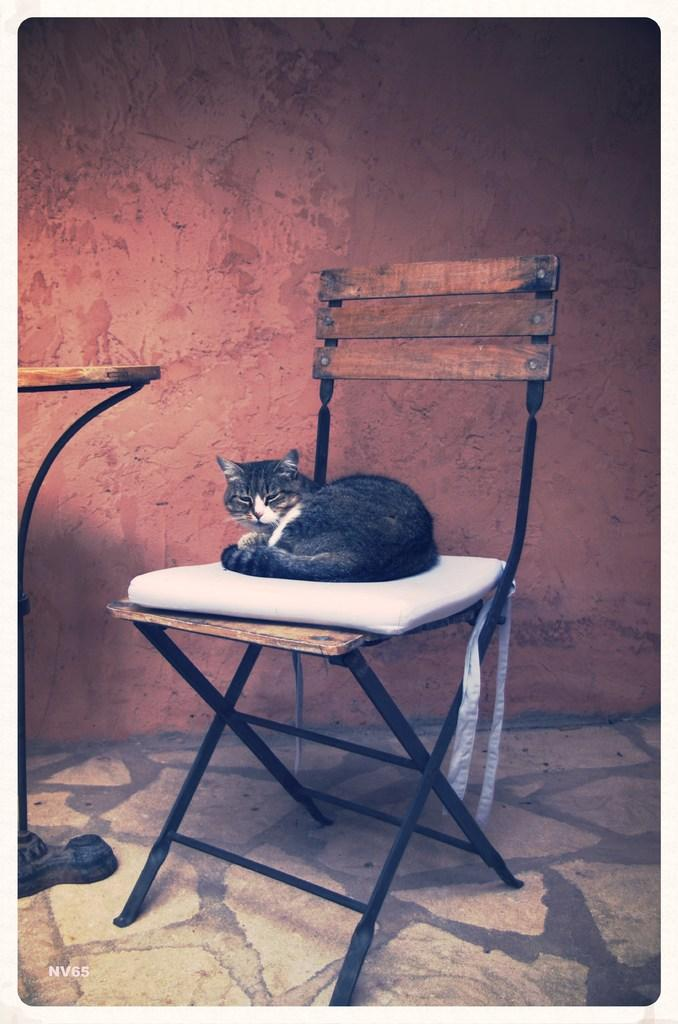What piece of furniture is present in the image? There is a chair in the image. What is placed on the chair? There is a pillow on the chair. What type of animal is sitting on the pillow? There is a black color cat on the pillow. What can be seen behind the chair in the image? There is a wall visible in the background of the image. Where is the comb used by the cat in the image? There is no comb present in the image, and the cat is not using one. 